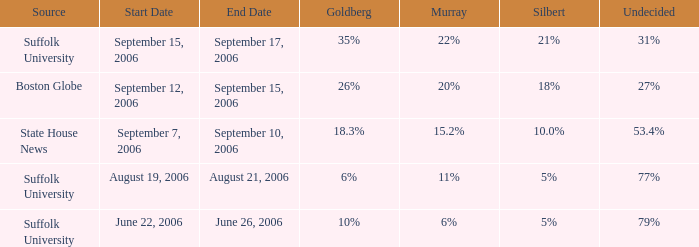0%? September 7–10, 2006. 